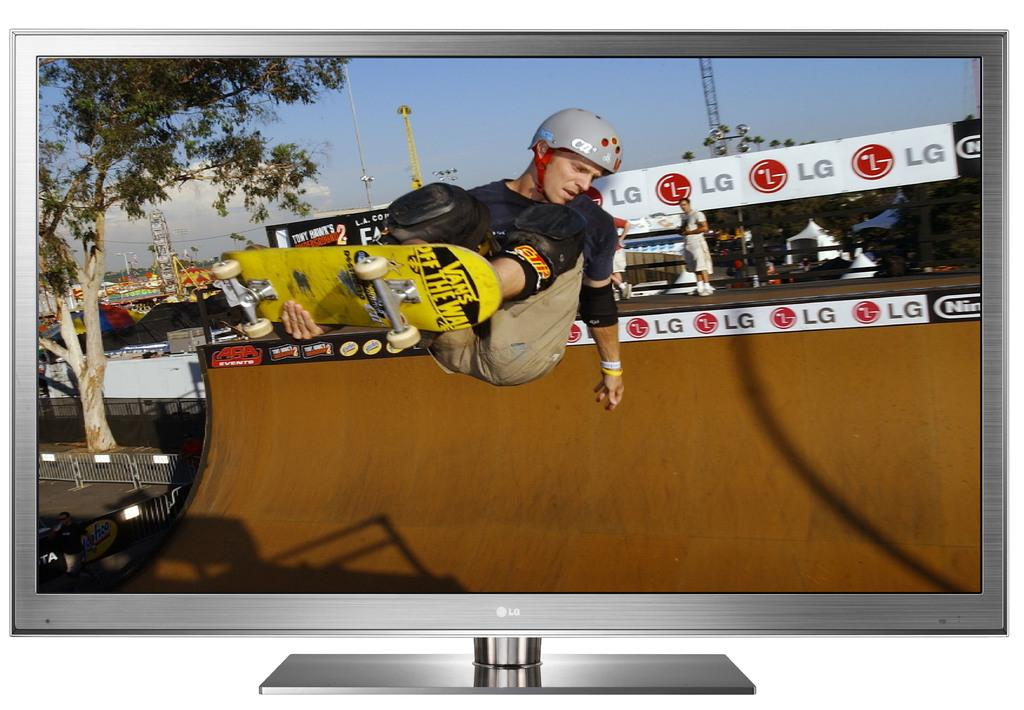<image>
Give a short and clear explanation of the subsequent image. a man skating near some LG ads above the ramp 